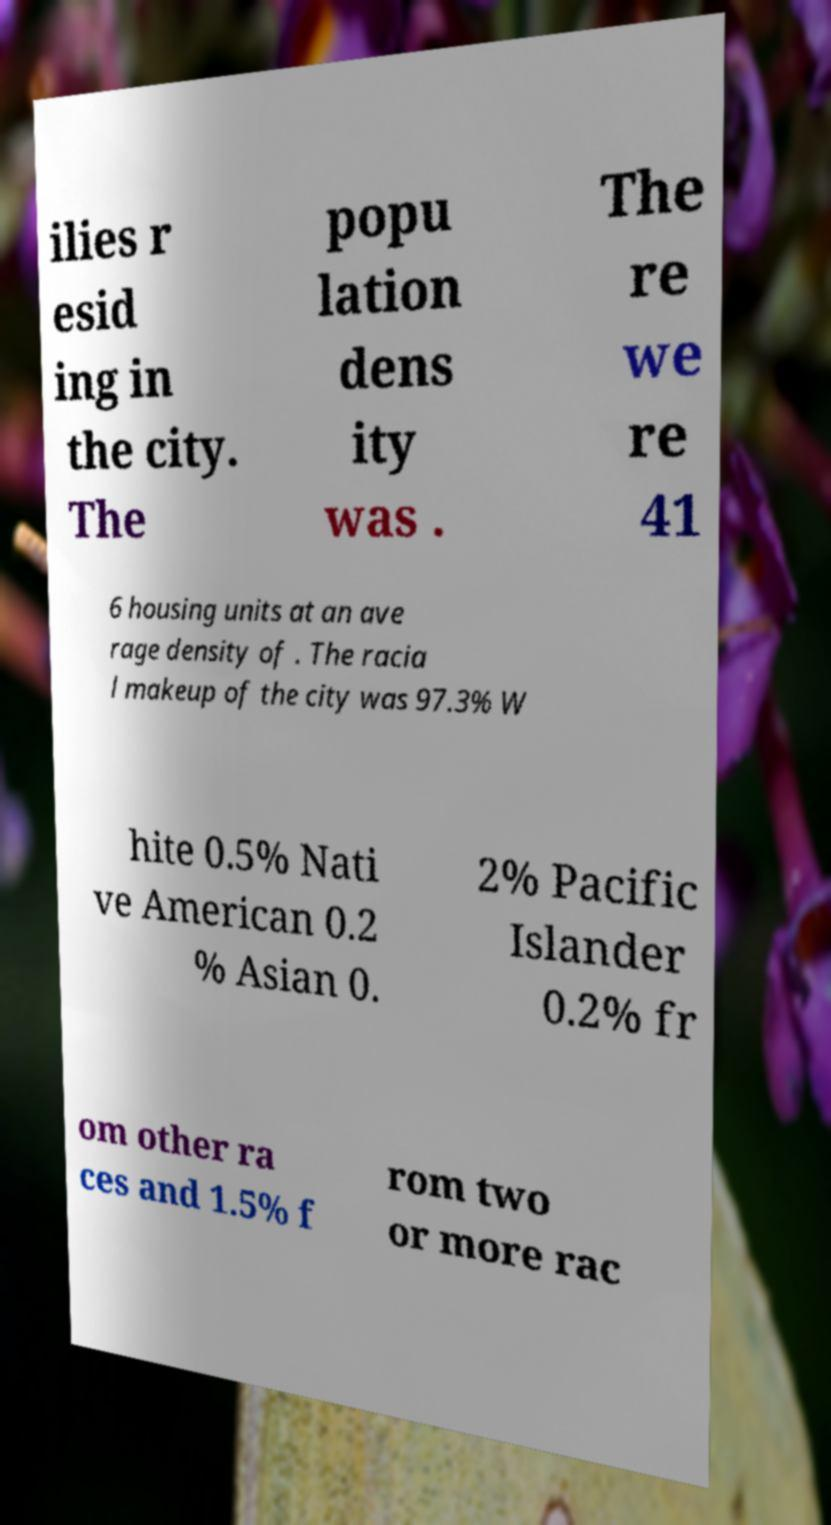I need the written content from this picture converted into text. Can you do that? ilies r esid ing in the city. The popu lation dens ity was . The re we re 41 6 housing units at an ave rage density of . The racia l makeup of the city was 97.3% W hite 0.5% Nati ve American 0.2 % Asian 0. 2% Pacific Islander 0.2% fr om other ra ces and 1.5% f rom two or more rac 